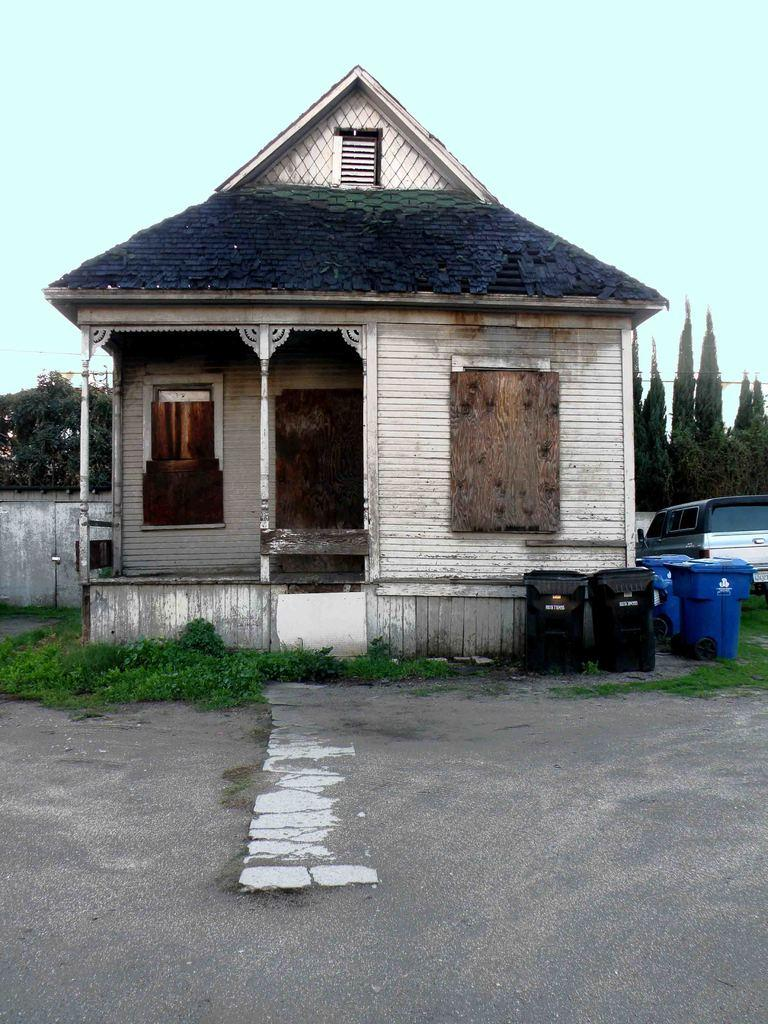What type of structure is visible in the image? There is a small house in the image. Where are the dustbins located in the image? The dustbins are on the right side of the image. What else can be seen on the right side of the image? There is a car on the right side of the image. What is at the bottom of the image? There is a road at the bottom of the image. What is visible in the background of the image? There are trees in the background of the image. What is visible at the top of the image? The sky is visible at the top of the image. What type of chalk is being used to draw on the road in the image? There is no chalk present in the image, and no one is drawing on the road. What season is depicted in the image, considering the presence of trees and the sky? The image does not provide enough information to determine the season, as trees and the sky can be present in any season. 